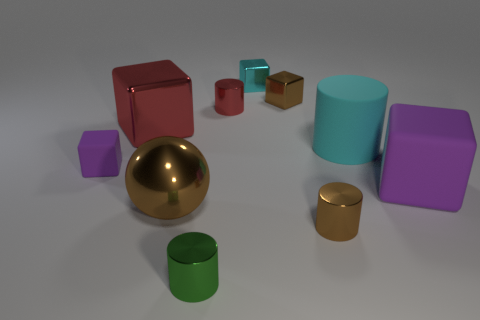The small metal thing that is both to the right of the small green metallic cylinder and on the left side of the tiny cyan thing is what color?
Your answer should be very brief. Red. Are there more brown objects that are to the right of the brown shiny cube than red cylinders that are in front of the large brown metal sphere?
Your response must be concise. Yes. The sphere that is the same material as the green object is what size?
Keep it short and to the point. Large. There is a red object on the right side of the shiny ball; how many big brown objects are in front of it?
Your answer should be compact. 1. Is there a tiny cyan metallic thing that has the same shape as the tiny purple object?
Provide a succinct answer. Yes. There is a large shiny object right of the big cube that is to the left of the small cyan metallic thing; what color is it?
Your answer should be compact. Brown. Is the number of large cyan cylinders greater than the number of purple metallic cylinders?
Make the answer very short. Yes. What number of gray metal cubes are the same size as the cyan shiny object?
Provide a succinct answer. 0. Is the material of the large brown thing the same as the cyan object that is left of the large cylinder?
Offer a very short reply. Yes. Are there fewer tiny cyan metal blocks than tiny blue metallic cylinders?
Provide a succinct answer. No. 